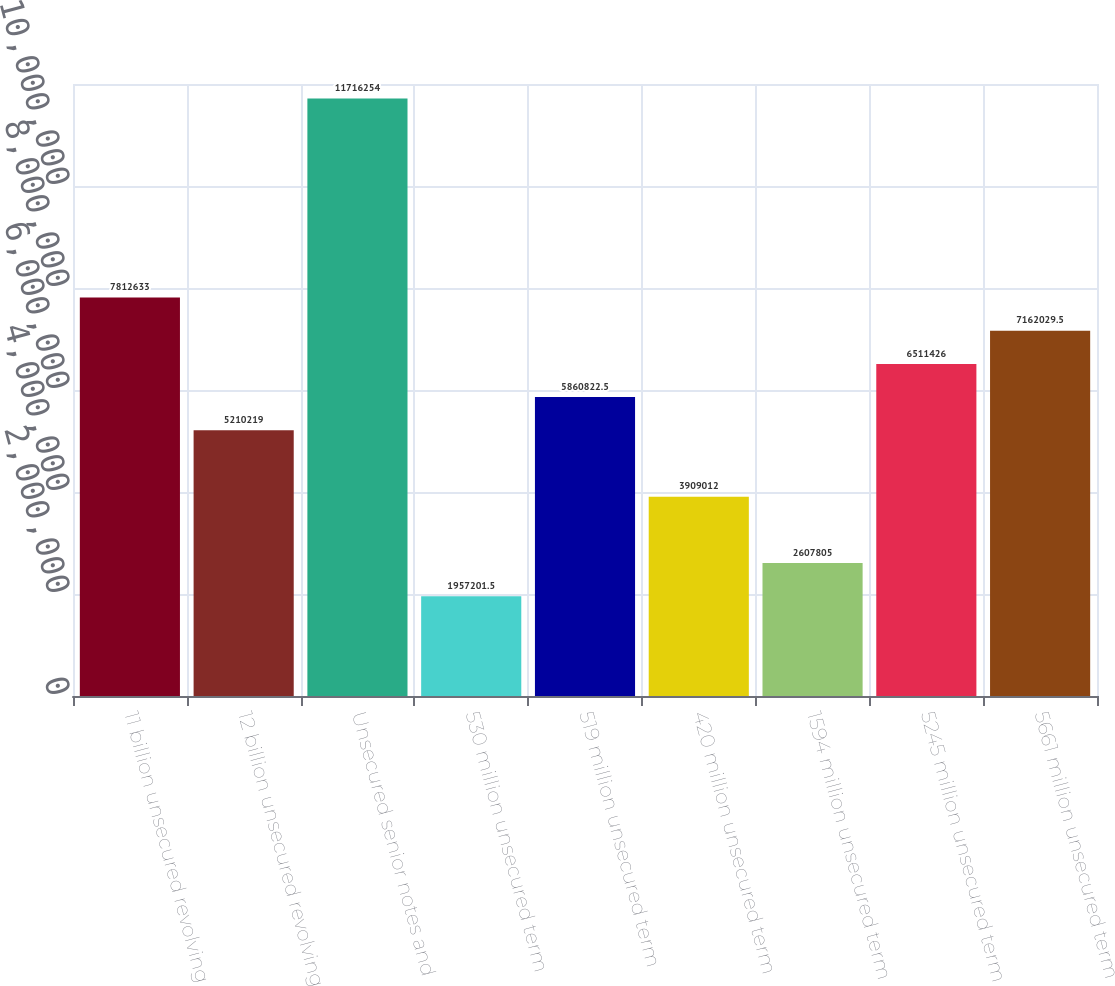Convert chart. <chart><loc_0><loc_0><loc_500><loc_500><bar_chart><fcel>11 billion unsecured revolving<fcel>12 billion unsecured revolving<fcel>Unsecured senior notes and<fcel>530 million unsecured term<fcel>519 million unsecured term<fcel>420 million unsecured term<fcel>1594 million unsecured term<fcel>5245 million unsecured term<fcel>5661 million unsecured term<nl><fcel>7.81263e+06<fcel>5.21022e+06<fcel>1.17163e+07<fcel>1.9572e+06<fcel>5.86082e+06<fcel>3.90901e+06<fcel>2.6078e+06<fcel>6.51143e+06<fcel>7.16203e+06<nl></chart> 